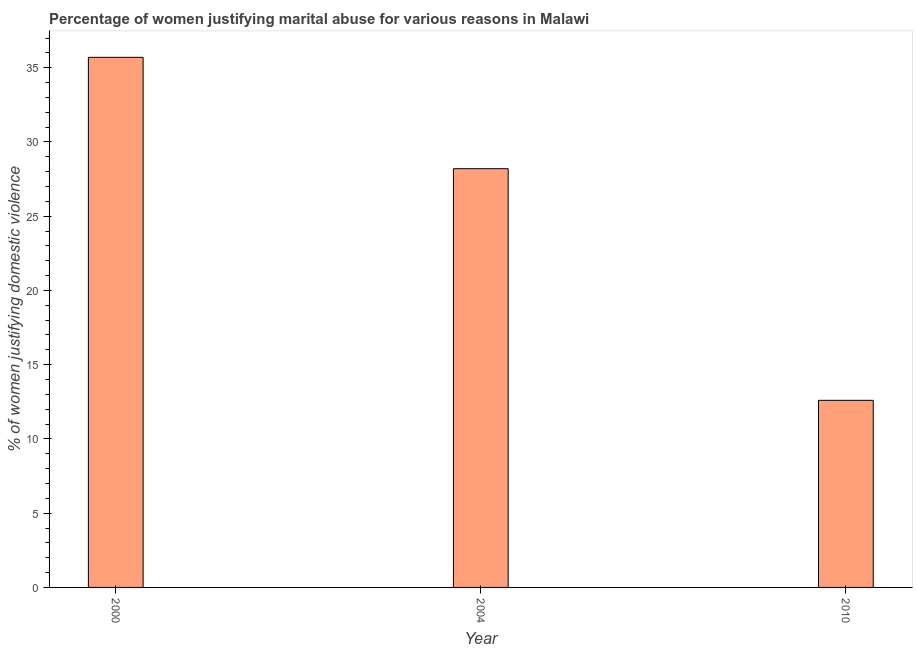Does the graph contain any zero values?
Offer a very short reply. No. What is the title of the graph?
Offer a very short reply. Percentage of women justifying marital abuse for various reasons in Malawi. What is the label or title of the Y-axis?
Provide a short and direct response. % of women justifying domestic violence. What is the percentage of women justifying marital abuse in 2000?
Give a very brief answer. 35.7. Across all years, what is the maximum percentage of women justifying marital abuse?
Your answer should be very brief. 35.7. Across all years, what is the minimum percentage of women justifying marital abuse?
Offer a terse response. 12.6. What is the sum of the percentage of women justifying marital abuse?
Keep it short and to the point. 76.5. What is the difference between the percentage of women justifying marital abuse in 2004 and 2010?
Give a very brief answer. 15.6. What is the median percentage of women justifying marital abuse?
Offer a terse response. 28.2. In how many years, is the percentage of women justifying marital abuse greater than 22 %?
Make the answer very short. 2. What is the ratio of the percentage of women justifying marital abuse in 2000 to that in 2004?
Provide a short and direct response. 1.27. Is the difference between the percentage of women justifying marital abuse in 2000 and 2010 greater than the difference between any two years?
Offer a terse response. Yes. What is the difference between the highest and the lowest percentage of women justifying marital abuse?
Your answer should be very brief. 23.1. In how many years, is the percentage of women justifying marital abuse greater than the average percentage of women justifying marital abuse taken over all years?
Your answer should be compact. 2. Are the values on the major ticks of Y-axis written in scientific E-notation?
Make the answer very short. No. What is the % of women justifying domestic violence of 2000?
Your answer should be very brief. 35.7. What is the % of women justifying domestic violence of 2004?
Keep it short and to the point. 28.2. What is the % of women justifying domestic violence of 2010?
Ensure brevity in your answer.  12.6. What is the difference between the % of women justifying domestic violence in 2000 and 2010?
Your answer should be very brief. 23.1. What is the ratio of the % of women justifying domestic violence in 2000 to that in 2004?
Your response must be concise. 1.27. What is the ratio of the % of women justifying domestic violence in 2000 to that in 2010?
Your answer should be very brief. 2.83. What is the ratio of the % of women justifying domestic violence in 2004 to that in 2010?
Provide a succinct answer. 2.24. 